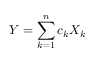Convert formula to latex. <formula><loc_0><loc_0><loc_500><loc_500>Y = \sum _ { k = 1 } ^ { n } c _ { k } X _ { k }</formula> 